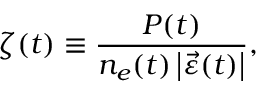<formula> <loc_0><loc_0><loc_500><loc_500>\zeta ( t ) \equiv \frac { P ( t ) } { n _ { e } ( t ) \left | \ V e c { \varepsilon } ( t ) \right | } ,</formula> 